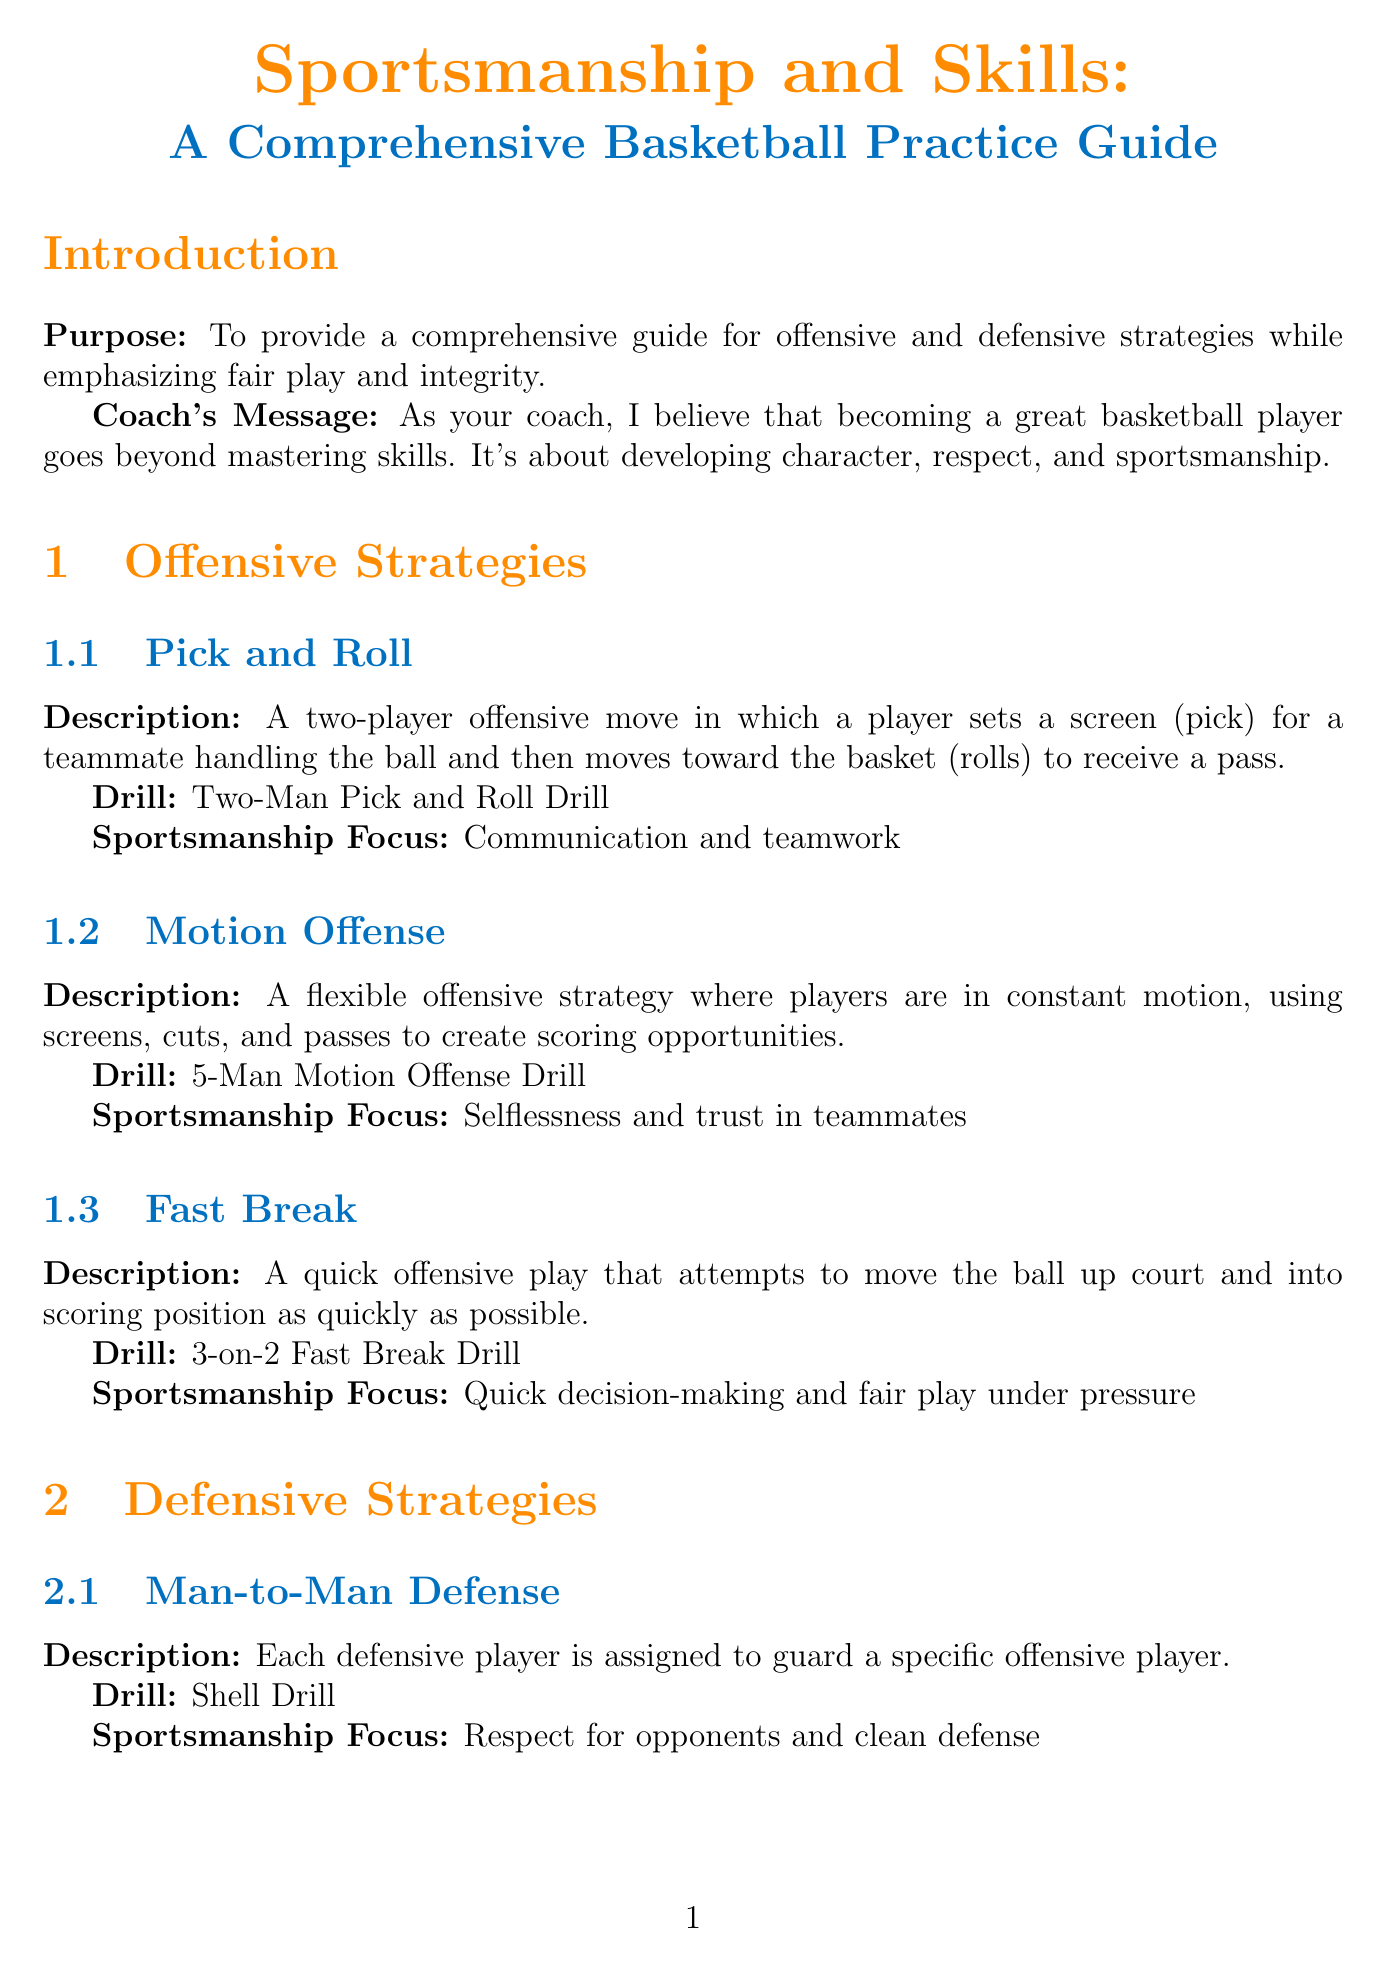What is the title of the manual? The title of the manual is stated at the very beginning of the document in a larger font.
Answer: Sportsmanship and Skills: A Comprehensive Basketball Practice Guide What is the purpose of the manual? The purpose is explicitly mentioned in the introduction section of the document.
Answer: To provide a comprehensive guide for offensive and defensive strategies while emphasizing fair play and integrity What drill is associated with the Pick and Roll strategy? Each offensive strategy includes a specific drill name that follows its description in the document.
Answer: Two-Man Pick and Roll Drill What is the sportsmanship focus of the Shell Drill? Each defensive strategy drill has a designated sportsmanship focus that is mentioned below the drill name.
Answer: Respect for opponents and clean defense How many drills are listed under Shooting? The fundamental skills section lists the number of drills under each skill area.
Answer: Three What is the sportsmanship focus when practicing Dribbling? Each skill's drills are accompanied by a sportsmanship focus that highlights the values associated with that skill.
Answer: Ball control and fair play Name a team-building activity mentioned in the manual. The document details specific team-building activities that support character development among players.
Answer: Trust Fall Which sportsmanship guideline emphasizes player conduct towards officials? The manual outlines specific fair play guidelines that emphasize proper conduct during games.
Answer: Respect officials' decisions What does Michael Jordan's quote in the conclusion highlight? The quote reflects a deeper lesson about success and failure, relating it to the overall theme of the manual.
Answer: Character development and resilience 